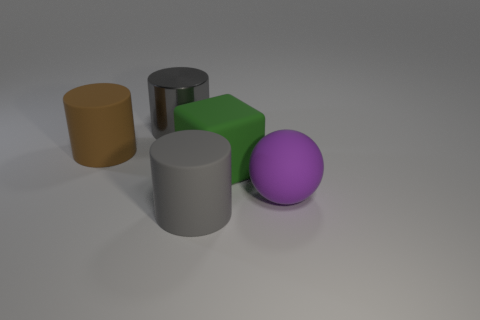Add 5 big cyan matte blocks. How many objects exist? 10 Subtract all cylinders. How many objects are left? 2 Add 2 metallic cylinders. How many metallic cylinders exist? 3 Subtract 0 yellow cylinders. How many objects are left? 5 Subtract all purple balls. Subtract all large purple matte balls. How many objects are left? 3 Add 1 rubber spheres. How many rubber spheres are left? 2 